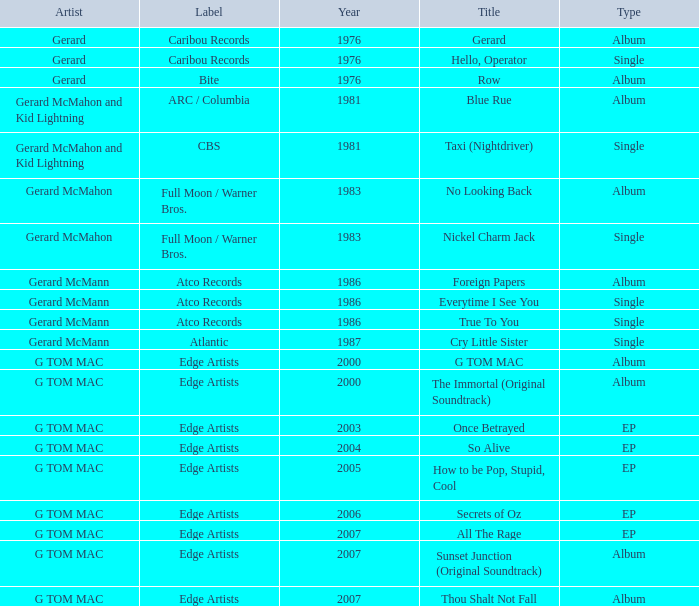Which Title has a Type of album in 1983? No Looking Back. 